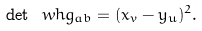<formula> <loc_0><loc_0><loc_500><loc_500>\det \ w h g _ { a b } = ( x _ { v } - y _ { u } ) ^ { 2 } .</formula> 